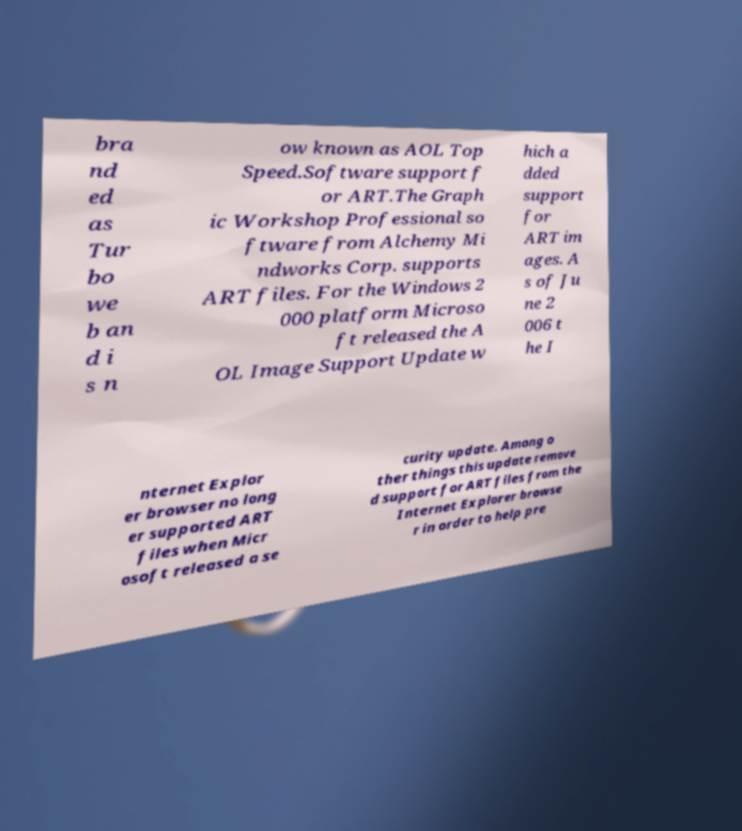Can you accurately transcribe the text from the provided image for me? bra nd ed as Tur bo we b an d i s n ow known as AOL Top Speed.Software support f or ART.The Graph ic Workshop Professional so ftware from Alchemy Mi ndworks Corp. supports ART files. For the Windows 2 000 platform Microso ft released the A OL Image Support Update w hich a dded support for ART im ages. A s of Ju ne 2 006 t he I nternet Explor er browser no long er supported ART files when Micr osoft released a se curity update. Among o ther things this update remove d support for ART files from the Internet Explorer browse r in order to help pre 